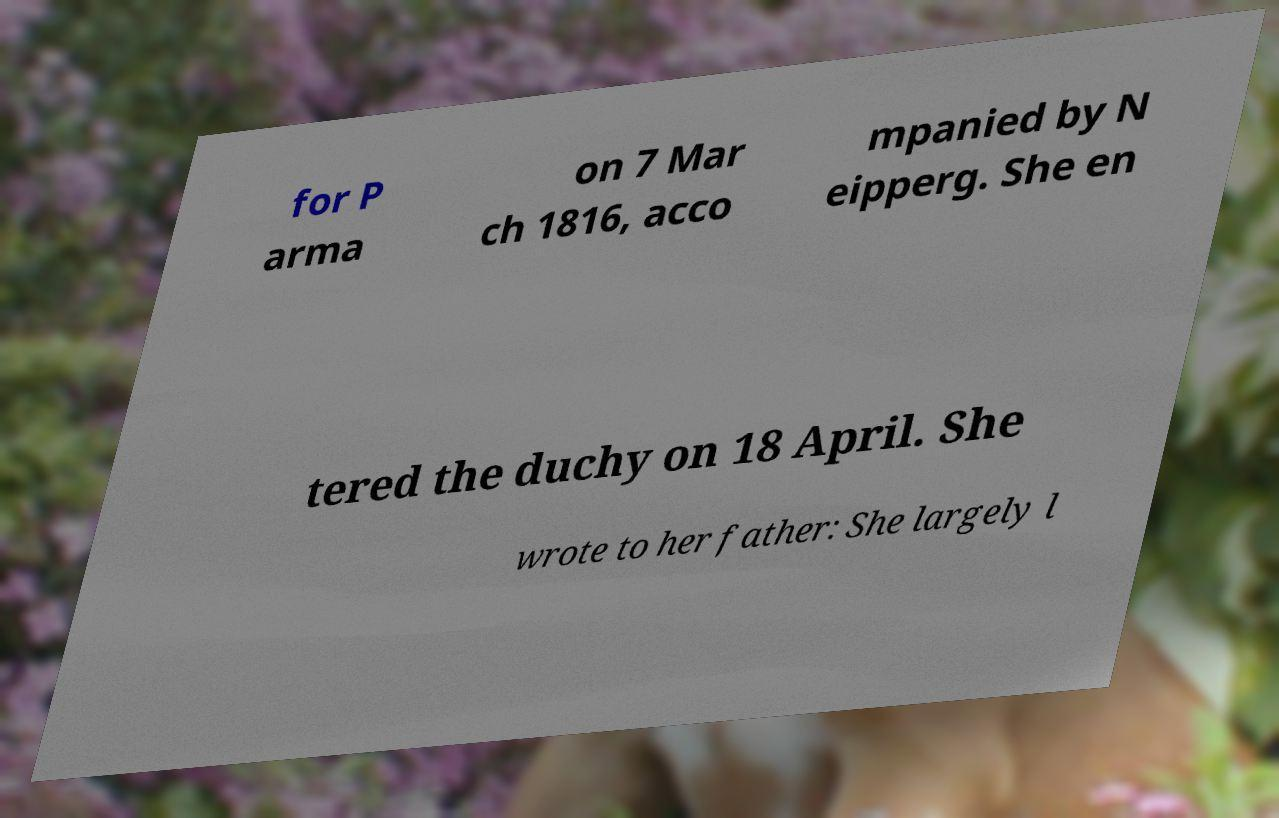There's text embedded in this image that I need extracted. Can you transcribe it verbatim? for P arma on 7 Mar ch 1816, acco mpanied by N eipperg. She en tered the duchy on 18 April. She wrote to her father: She largely l 